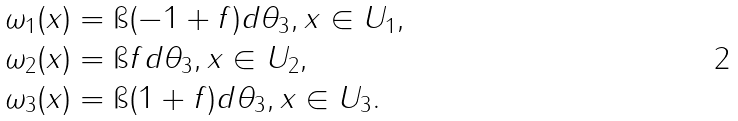Convert formula to latex. <formula><loc_0><loc_0><loc_500><loc_500>\omega _ { 1 } ( x ) & = \i ( - 1 + f ) d \theta _ { 3 } , x \in U _ { 1 } , \\ \omega _ { 2 } ( x ) & = \i f d \theta _ { 3 } , x \in U _ { 2 } , \\ \omega _ { 3 } ( x ) & = \i ( 1 + f ) d \theta _ { 3 } , x \in U _ { 3 } .</formula> 